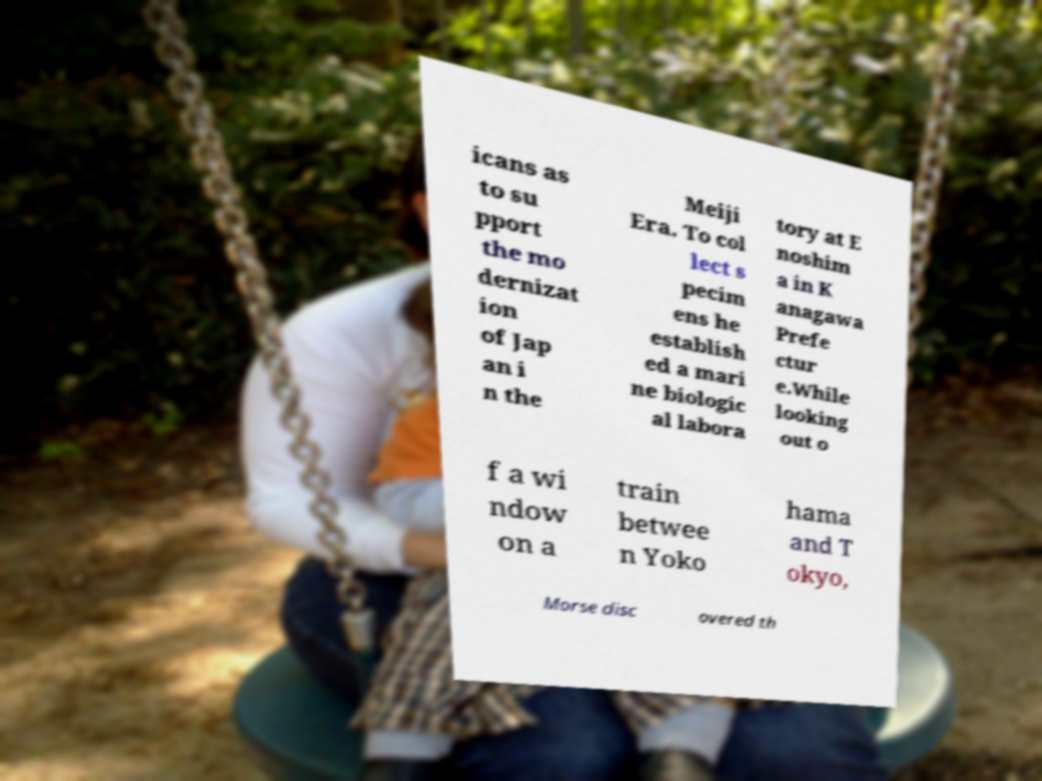For documentation purposes, I need the text within this image transcribed. Could you provide that? icans as to su pport the mo dernizat ion of Jap an i n the Meiji Era. To col lect s pecim ens he establish ed a mari ne biologic al labora tory at E noshim a in K anagawa Prefe ctur e.While looking out o f a wi ndow on a train betwee n Yoko hama and T okyo, Morse disc overed th 